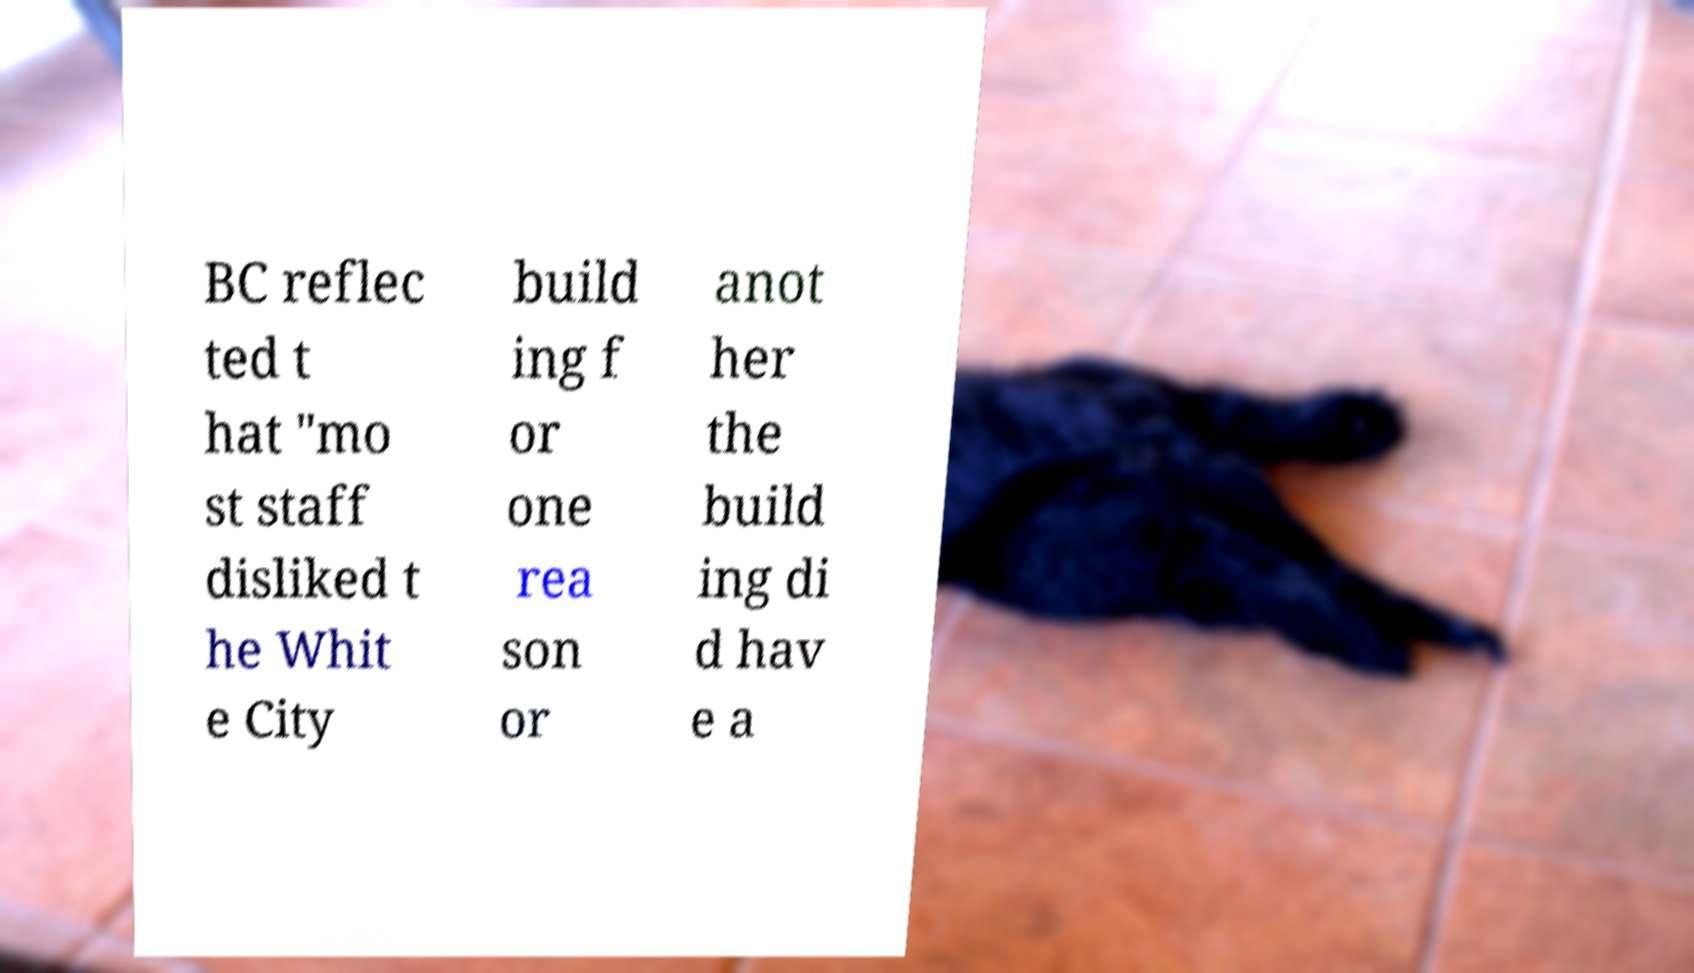Please read and relay the text visible in this image. What does it say? BC reflec ted t hat "mo st staff disliked t he Whit e City build ing f or one rea son or anot her the build ing di d hav e a 